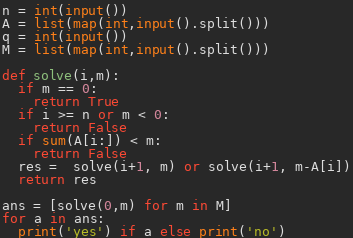<code> <loc_0><loc_0><loc_500><loc_500><_Python_>n = int(input())
A = list(map(int,input().split()))
q = int(input())
M = list(map(int,input().split()))

def solve(i,m):
  if m == 0:
    return True
  if i >= n or m < 0:
    return False
  if sum(A[i:]) < m:
    return False
  res =  solve(i+1, m) or solve(i+1, m-A[i])
  return res

ans = [solve(0,m) for m in M]
for a in ans:
  print('yes') if a else print('no')
</code> 